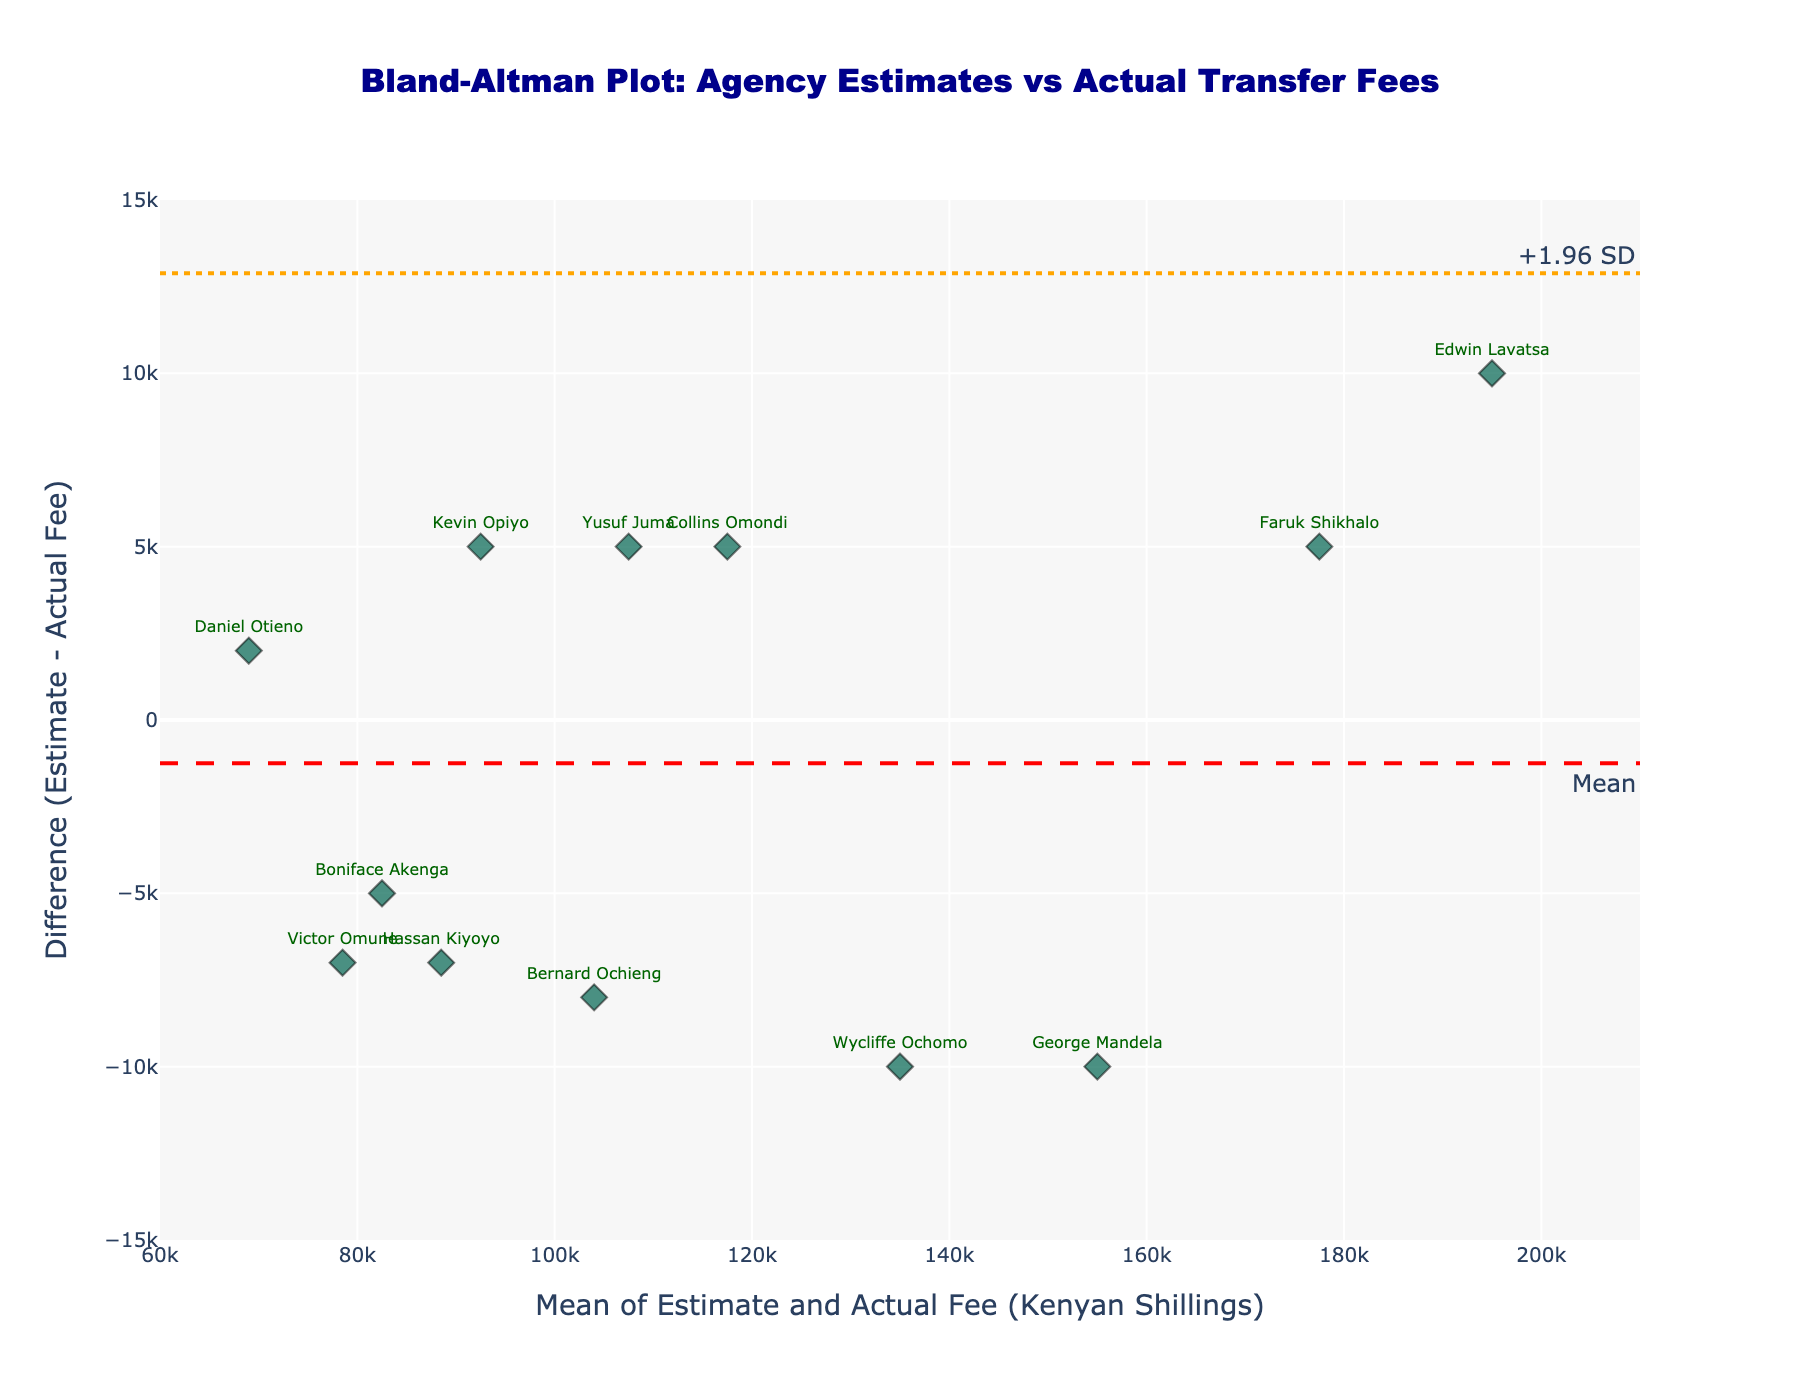what is the title of the figure? Look at the top of the plot where the title is displayed.
Answer: Bland-Altman Plot: Agency Estimates vs Actual Transfer Fees how many players are shown in the figure? Count the number of markers, one for each player.
Answer: 12 what is the mean of the differences in estimates and actual fees? The horizontal dashed red line represents the mean difference. Look at the annotation text on the line.
Answer: Mean what are the limits of agreement shown in the figure? The horizontal dotted orange lines represent the limits of agreement. Look at the annotation texts on these lines.
Answer: -1.96 SD and +1.96 SD what is the difference between agency estimate and actual transfer fee for Victor Omune? Find the data point labeled "Victor Omune" and observe its vertical position on the y-axis.
Answer: -7000 which player has the highest positive difference between agency estimate and actual transfer fee? Identify the player labeled on the highest point above the mean difference line (y-axis).
Answer: Hassan Kiyoyo which player has the most accurate agency estimate? Look for the player closest to the mean difference (red line) on the y-axis. The smallest difference indicates the most accurate estimate.
Answer: Daniel Otieno is there a general trend in how agency estimates compare to actual fees? Observe the distribution of data points in relation to the mean difference line to see if estimates are generally higher or lower than actual fees.
Answer: Agency estimates tend to be higher calculate the mean of the actual transfer fees for all players. Sum all actual transfer fees from the data and divide by the number of players.
Answer: 114833.33 estimate the variance of the differences between agency estimates and actual transfer fees using the limits of agreement. The variance squared (std diff) corresponds to the difference from the mean difference to the -1.96 SD or +1.96 SD limits divided by 1.96.
Answer: 4908.16 